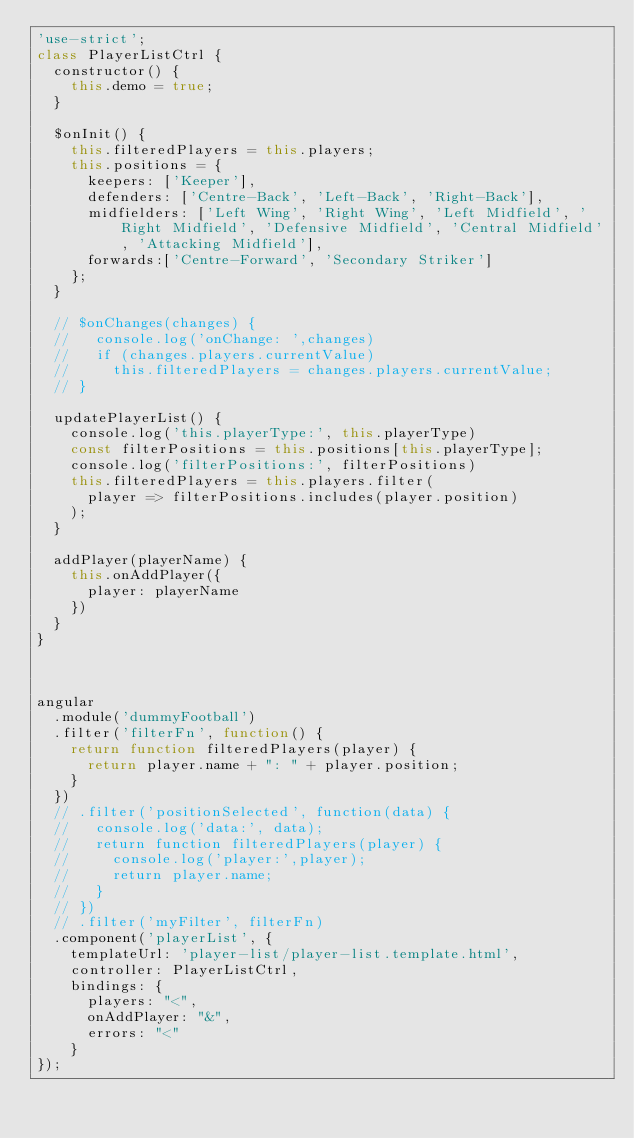Convert code to text. <code><loc_0><loc_0><loc_500><loc_500><_JavaScript_>'use-strict';
class PlayerListCtrl {
  constructor() {
    this.demo = true;
  }

  $onInit() {
    this.filteredPlayers = this.players;
    this.positions = {
      keepers: ['Keeper'],
      defenders: ['Centre-Back', 'Left-Back', 'Right-Back'],
      midfielders: ['Left Wing', 'Right Wing', 'Left Midfield', 'Right Midfield', 'Defensive Midfield', 'Central Midfield', 'Attacking Midfield'],
      forwards:['Centre-Forward', 'Secondary Striker']
    };
  }

  // $onChanges(changes) {
  //   console.log('onChange: ',changes)
  //   if (changes.players.currentValue)
  //     this.filteredPlayers = changes.players.currentValue;
  // }

  updatePlayerList() {
    console.log('this.playerType:', this.playerType)
    const filterPositions = this.positions[this.playerType];
    console.log('filterPositions:', filterPositions)
    this.filteredPlayers = this.players.filter(
      player => filterPositions.includes(player.position)
    );
  }

  addPlayer(playerName) {
    this.onAddPlayer({
      player: playerName
    })
  }
}



angular
  .module('dummyFootball')
  .filter('filterFn', function() {
    return function filteredPlayers(player) {
      return player.name + ": " + player.position;
    }
  })
  // .filter('positionSelected', function(data) {
  //   console.log('data:', data);
  //   return function filteredPlayers(player) {
  //     console.log('player:',player);
  //     return player.name;
  //   }
  // })
  // .filter('myFilter', filterFn)
  .component('playerList', {
    templateUrl: 'player-list/player-list.template.html',
    controller: PlayerListCtrl,
    bindings: {
      players: "<",
      onAddPlayer: "&",
      errors: "<"
    }
});
</code> 